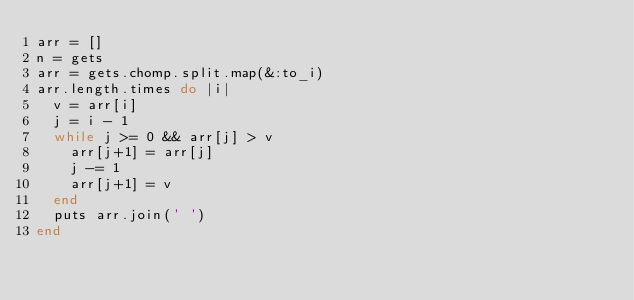<code> <loc_0><loc_0><loc_500><loc_500><_Ruby_>arr = []
n = gets
arr = gets.chomp.split.map(&:to_i)
arr.length.times do |i|
  v = arr[i]
  j = i - 1
  while j >= 0 && arr[j] > v
    arr[j+1] = arr[j]
    j -= 1
    arr[j+1] = v
  end
  puts arr.join(' ')
end
</code> 